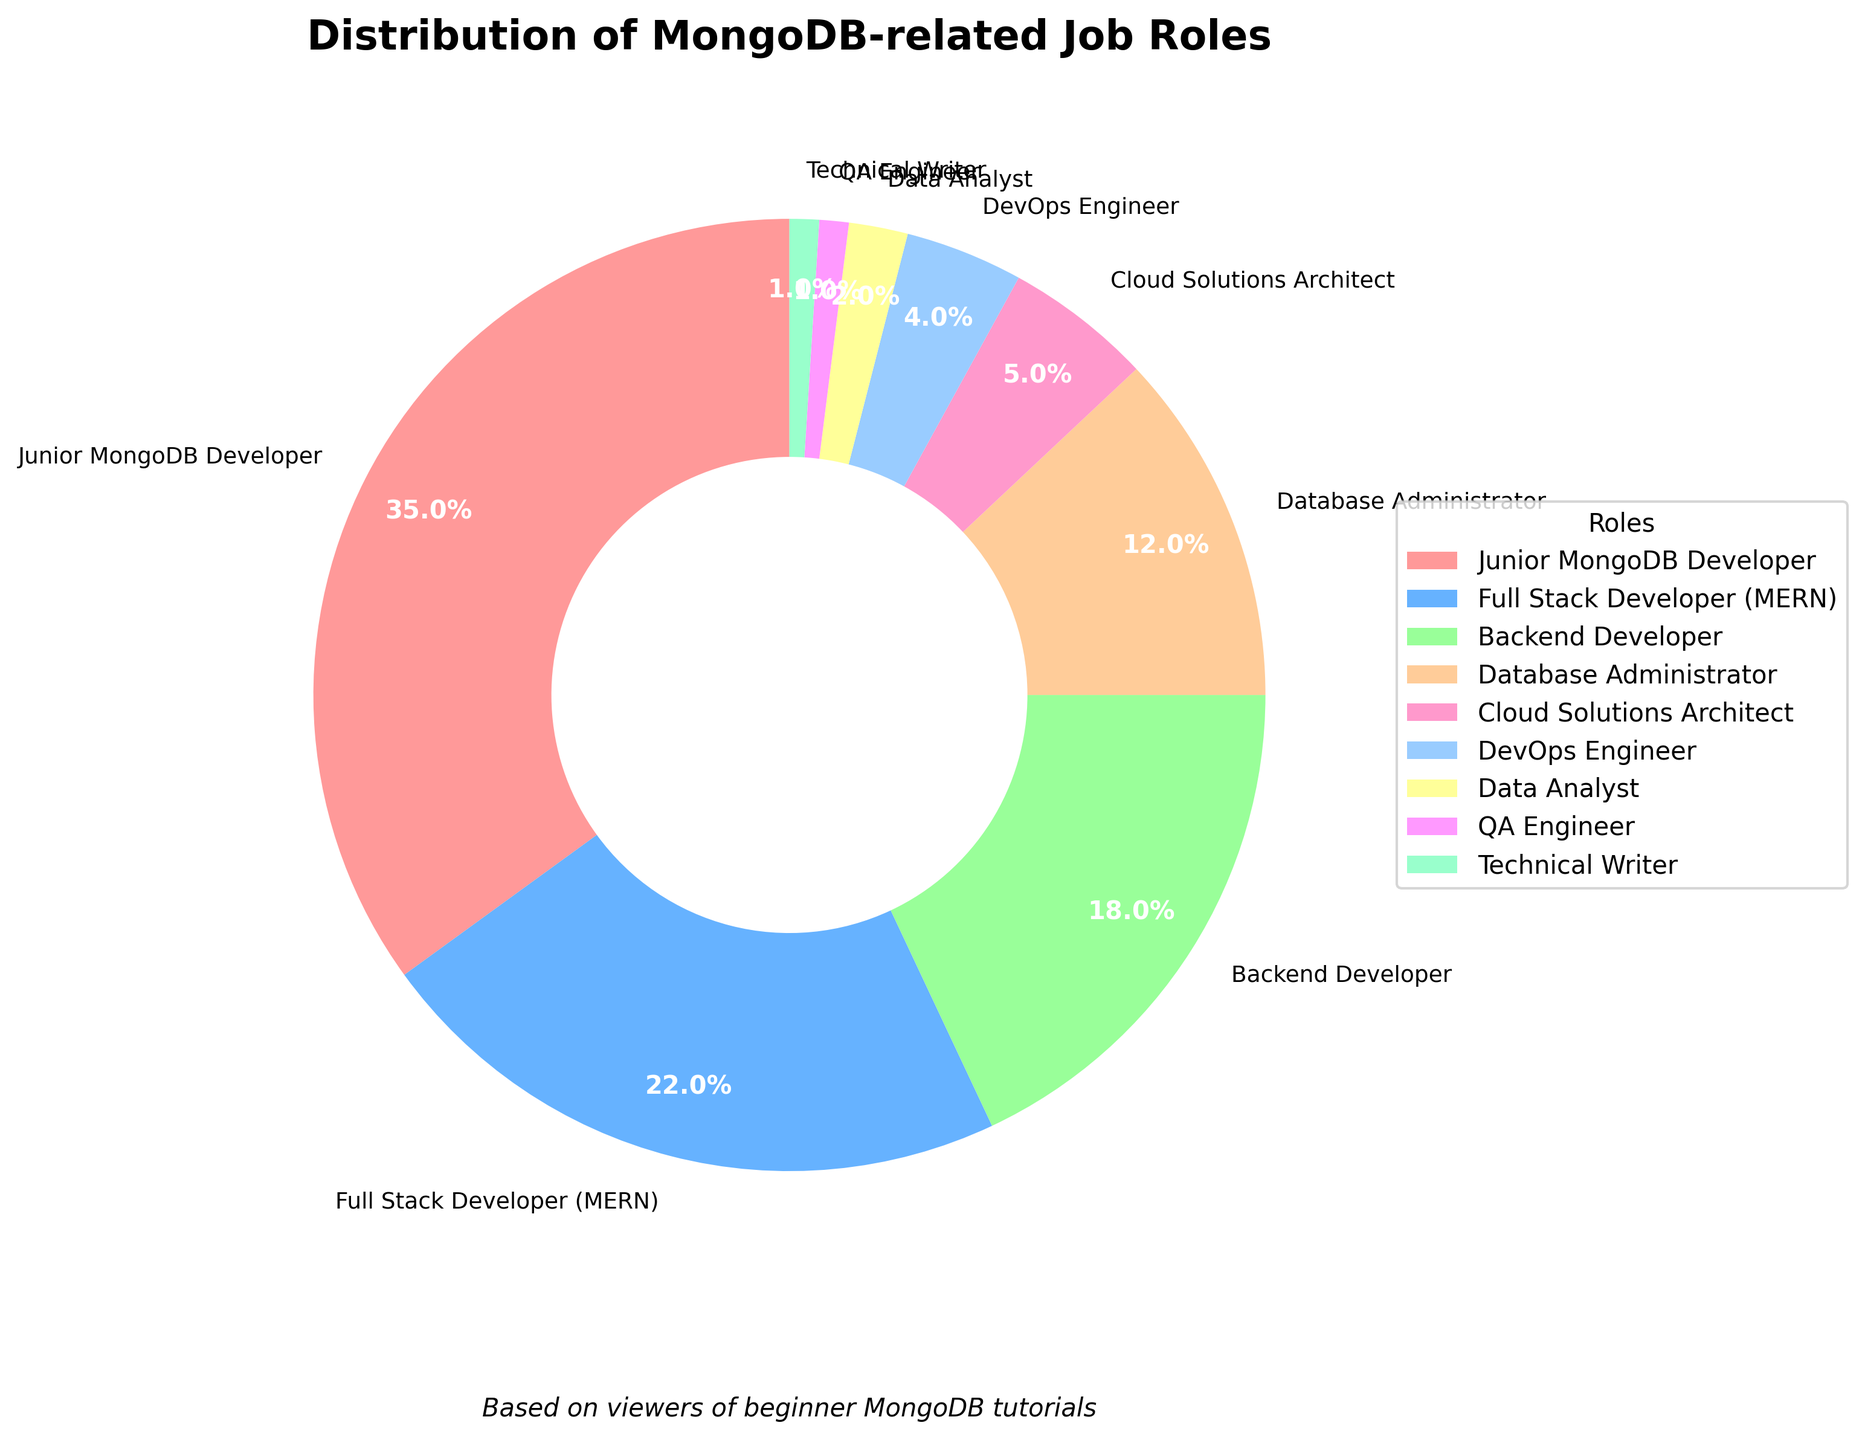What is the most common MongoDB-related job role among the viewers? Juniors MongoDB Developer has the largest slice of the pie chart, representing 35% of the viewers.
Answer: Junior MongoDB Developer Which roles together cover more than half of the viewer base? By examining the chart, we can see that Junior MongoDB Developer (35%) followed by Full Stack Developer (MERN) (22%) together surpass 50%. Summing them up, 35% + 22% = 57%. Therefore, these two roles together cover more than half of the viewer base.
Answer: Junior MongoDB Developer, Full Stack Developer (MERN) How much larger is the percentage of viewers interested in the Junior MongoDB Developer role compared to those interested in the DevOps Engineer role? Junior MongoDB Developer accounts for 35%, and DevOps Engineer accounts for 4%. The percentage difference is 35% - 4% = 31%.
Answer: 31% What is the combined percentage of viewers interested in Cloud Solutions Architect and Data Analyst roles? Cloud Solutions Architect accounts for 5% and Data Analyst accounts for 2%. The combined percentage is 5% + 2% = 7%.
Answer: 7% Which job role has the smallest representation among the viewers? The smallest slices of the pie chart are for QA Engineer (1%) and Technical Writer (1%). Since they are tied, both are the smallest representations.
Answer: QA Engineer, Technical Writer Is the percentage of viewers interested in Backend Developer larger than those interested in Database Administrator? Backend Developer accounts for 18%, while Database Administrator accounts for 12%. Comparing these percentages, 18% is larger than 12%.
Answer: Yes What percentage of viewers are interested in either becoming a Junior MongoDB Developer or a Backend Developer? Junior MongoDB Developer accounts for 35%, and Backend Developer accounts for 18%. Adding these percentages gives us 35% + 18% = 53%.
Answer: 53% How much smaller is the percentage of viewers interested in QA Engineer compared to Full Stack Developer (MERN)? QA Engineer accounts for 1%, and Full Stack Developer (MERN) accounts for 22%. The difference in percentage is 22% - 1% = 21%.
Answer: 21% What roles each contribute more than 10% to the viewer base? By examining the chart, we find that Junior MongoDB Developer (35%), Full Stack Developer (MERN) (22%), Backend Developer (18%), and Database Administrator (12%) each contribute more than 10%.
Answer: Junior MongoDB Developer, Full Stack Developer (MERN), Backend Developer, Database Administrator 